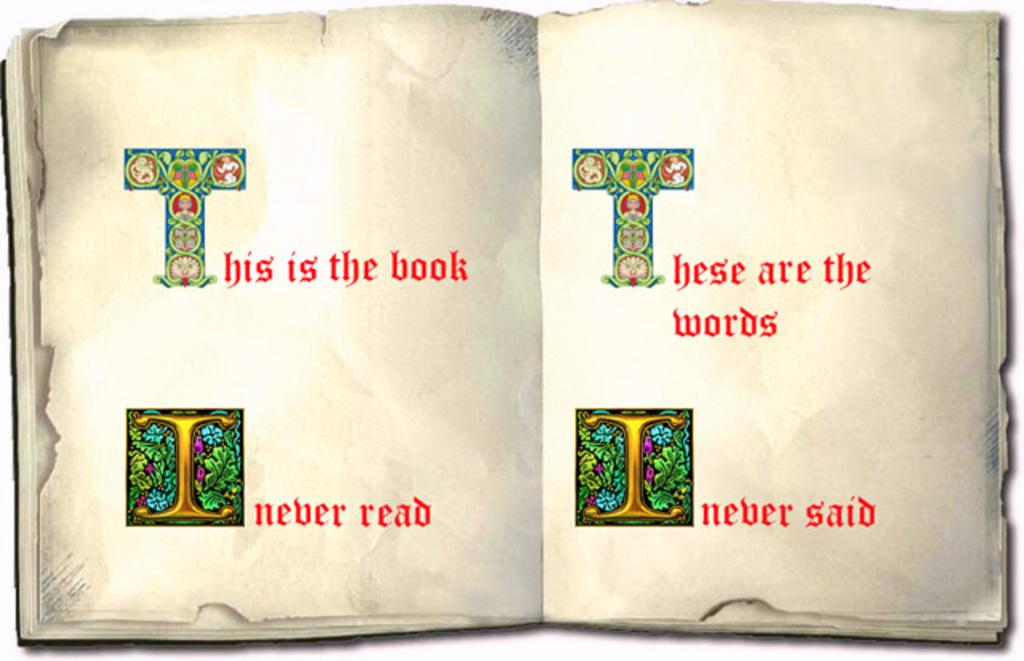What is the main object in the image? There is an open book in the image. What can be found on the pages of the book? The book has text on its pages, including the phrases "This is the book" and "These are the words". Are there any decorations on the pages of the book? Yes, the letters T and I are decorated on the two-sided pages. What type of furniture is depicted in the image? There is no furniture present in the image; it features an open book with text and decorations. Can you describe the fowl that is sitting on the book in the image? There is no fowl present in the image; it only features an open book. 